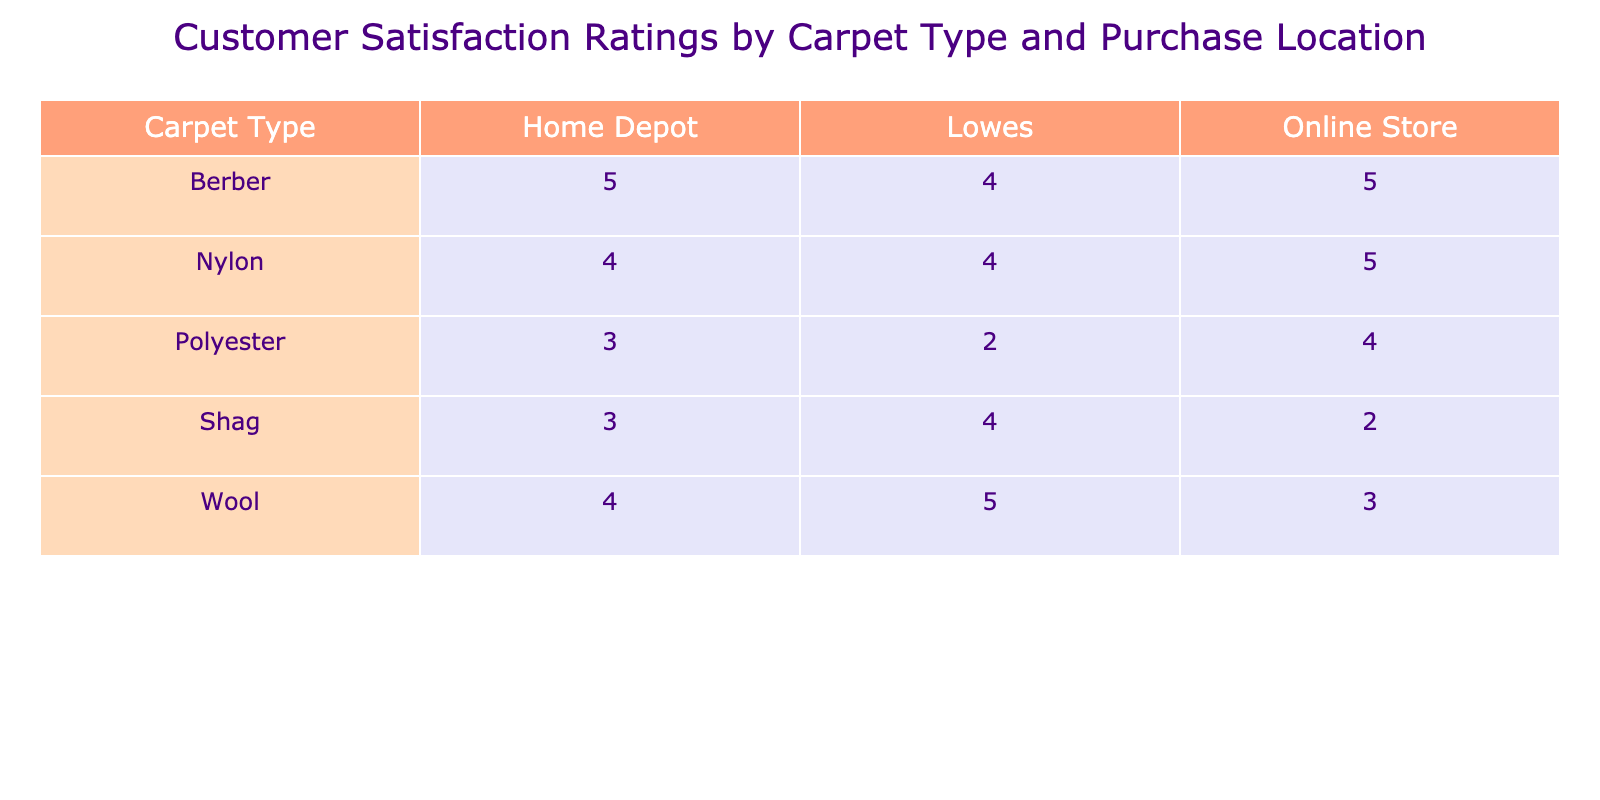What is the customer satisfaction rating for Wool carpets purchased from Lowes? The table shows that the customer satisfaction rating for Wool carpets at Lowes is 5.
Answer: 5 What purchase location had the highest average customer satisfaction rating for Nylon carpets? For Nylon carpets, the ratings from the table are 4 (Home Depot), 4 (Lowes), and 5 (Online Store). The highest is 5 from the Online Store.
Answer: Online Store Is the average customer satisfaction rating for Polyester carpets above 3? The ratings for Polyester carpets are 3, 2, and 4. Calculating the average: (3 + 2 + 4) / 3 = 3, which is not above 3.
Answer: No What is the difference in customer satisfaction ratings between Berber carpets at Home Depot and Shag carpets at Online Store? The rating for Berber carpets at Home Depot is 5 and for Shag carpets at Online Store is 2. The difference is 5 - 2 = 3.
Answer: 3 Which carpet type has the lowest overall average rating across all purchase locations? The average ratings per carpet type are: Wool (4.00), Nylon (4.33), Polyester (3.00), Berber (4.67), Shag (3.00). Both Polyester and Shag have the lowest average rating of 3.00.
Answer: Polyester and Shag How many carpet types have an average rating of 4 or higher? From the table, Wool (4.00), Nylon (4.33), and Berber (4.67) have ratings of 4 or higher. Therefore, there are 3 types.
Answer: 3 Is it true that customers were more satisfied with carpets bought from Home Depot compared to those bought Online? Looking at the average ratings: Home Depot ratings are Wool (4), Nylon (4), Polyester (3), Berber (5), Shag (3) which average to 3.8. Online ratings are Wool (3), Nylon (5), Polyester (4), Berber (5), Shag (2) which average to 3.8 as well. Therefore, the statement is false.
Answer: No What is the average customer satisfaction rating for carpets purchased from Lowes across all types? The ratings from the table for Lowes are: Wool (5), Nylon (4), Polyester (2), Berber (4), Shag (4). The average is (5 + 4 + 2 + 4 + 4) / 5 = 3.8.
Answer: 3.8 